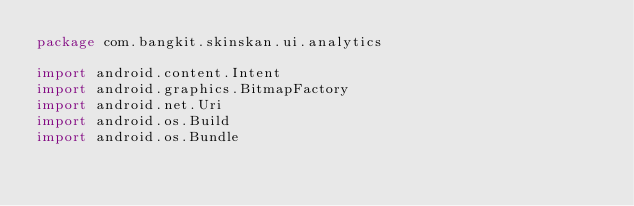Convert code to text. <code><loc_0><loc_0><loc_500><loc_500><_Kotlin_>package com.bangkit.skinskan.ui.analytics

import android.content.Intent
import android.graphics.BitmapFactory
import android.net.Uri
import android.os.Build
import android.os.Bundle</code> 